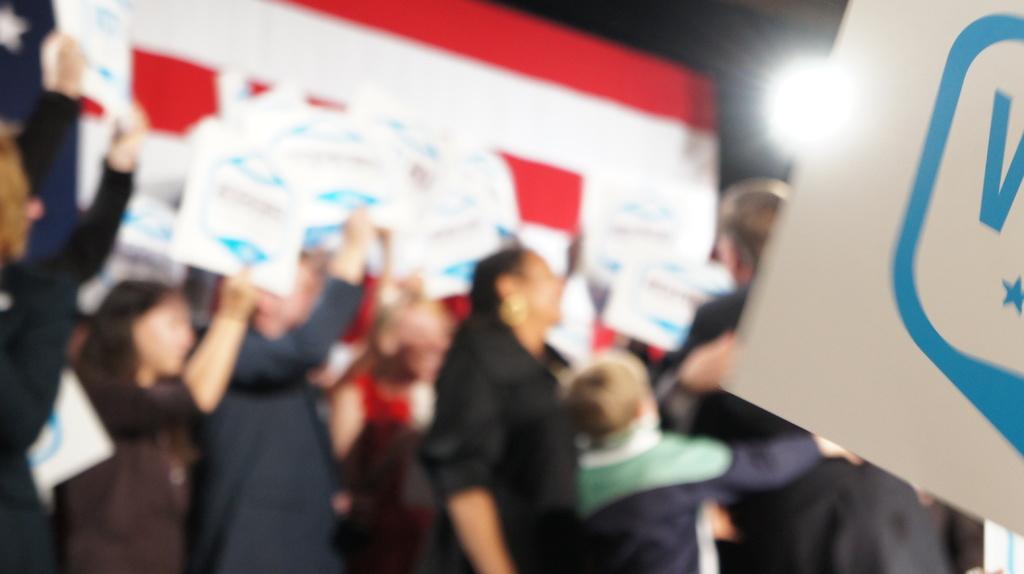How would you summarize this image in a sentence or two? In this image, we can see some people standing and they are holding some posters. We can see a banner and a light. 